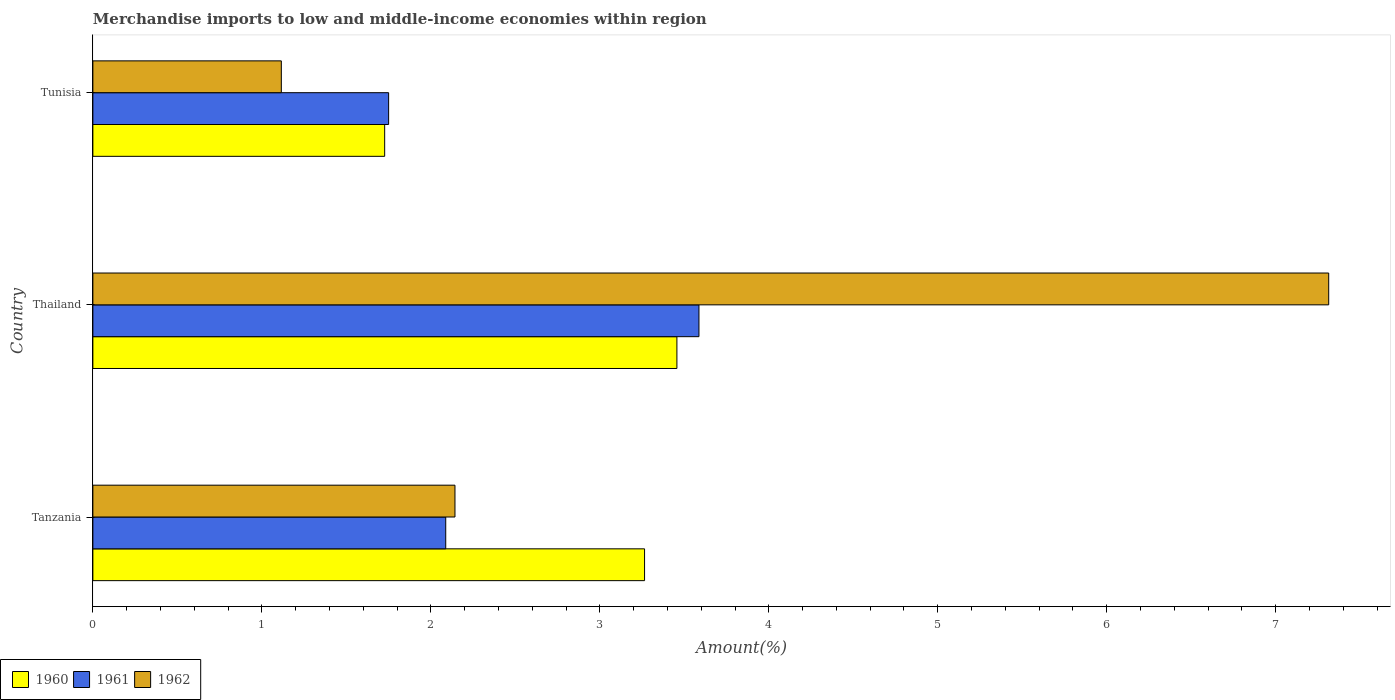Are the number of bars per tick equal to the number of legend labels?
Make the answer very short. Yes. How many bars are there on the 3rd tick from the bottom?
Keep it short and to the point. 3. What is the label of the 2nd group of bars from the top?
Your response must be concise. Thailand. In how many cases, is the number of bars for a given country not equal to the number of legend labels?
Your answer should be compact. 0. What is the percentage of amount earned from merchandise imports in 1960 in Tunisia?
Ensure brevity in your answer.  1.73. Across all countries, what is the maximum percentage of amount earned from merchandise imports in 1960?
Offer a terse response. 3.46. Across all countries, what is the minimum percentage of amount earned from merchandise imports in 1962?
Offer a very short reply. 1.12. In which country was the percentage of amount earned from merchandise imports in 1961 maximum?
Keep it short and to the point. Thailand. In which country was the percentage of amount earned from merchandise imports in 1961 minimum?
Your answer should be very brief. Tunisia. What is the total percentage of amount earned from merchandise imports in 1961 in the graph?
Keep it short and to the point. 7.43. What is the difference between the percentage of amount earned from merchandise imports in 1961 in Tanzania and that in Tunisia?
Your response must be concise. 0.34. What is the difference between the percentage of amount earned from merchandise imports in 1962 in Tunisia and the percentage of amount earned from merchandise imports in 1961 in Tanzania?
Your answer should be very brief. -0.97. What is the average percentage of amount earned from merchandise imports in 1960 per country?
Offer a very short reply. 2.82. What is the difference between the percentage of amount earned from merchandise imports in 1960 and percentage of amount earned from merchandise imports in 1962 in Tanzania?
Offer a terse response. 1.12. What is the ratio of the percentage of amount earned from merchandise imports in 1962 in Thailand to that in Tunisia?
Offer a terse response. 6.56. What is the difference between the highest and the second highest percentage of amount earned from merchandise imports in 1960?
Your response must be concise. 0.19. What is the difference between the highest and the lowest percentage of amount earned from merchandise imports in 1961?
Offer a terse response. 1.84. Is the sum of the percentage of amount earned from merchandise imports in 1960 in Tanzania and Tunisia greater than the maximum percentage of amount earned from merchandise imports in 1961 across all countries?
Your answer should be compact. Yes. What does the 3rd bar from the top in Tanzania represents?
Keep it short and to the point. 1960. What does the 2nd bar from the bottom in Tunisia represents?
Keep it short and to the point. 1961. Is it the case that in every country, the sum of the percentage of amount earned from merchandise imports in 1960 and percentage of amount earned from merchandise imports in 1962 is greater than the percentage of amount earned from merchandise imports in 1961?
Provide a succinct answer. Yes. Are the values on the major ticks of X-axis written in scientific E-notation?
Your answer should be very brief. No. How many legend labels are there?
Your answer should be compact. 3. What is the title of the graph?
Ensure brevity in your answer.  Merchandise imports to low and middle-income economies within region. Does "1982" appear as one of the legend labels in the graph?
Your answer should be compact. No. What is the label or title of the X-axis?
Ensure brevity in your answer.  Amount(%). What is the label or title of the Y-axis?
Provide a succinct answer. Country. What is the Amount(%) in 1960 in Tanzania?
Your response must be concise. 3.26. What is the Amount(%) in 1961 in Tanzania?
Your response must be concise. 2.09. What is the Amount(%) in 1962 in Tanzania?
Offer a terse response. 2.14. What is the Amount(%) in 1960 in Thailand?
Your response must be concise. 3.46. What is the Amount(%) in 1961 in Thailand?
Your answer should be very brief. 3.59. What is the Amount(%) in 1962 in Thailand?
Make the answer very short. 7.31. What is the Amount(%) in 1960 in Tunisia?
Provide a succinct answer. 1.73. What is the Amount(%) in 1961 in Tunisia?
Provide a short and direct response. 1.75. What is the Amount(%) in 1962 in Tunisia?
Provide a short and direct response. 1.12. Across all countries, what is the maximum Amount(%) of 1960?
Ensure brevity in your answer.  3.46. Across all countries, what is the maximum Amount(%) of 1961?
Make the answer very short. 3.59. Across all countries, what is the maximum Amount(%) of 1962?
Provide a succinct answer. 7.31. Across all countries, what is the minimum Amount(%) in 1960?
Give a very brief answer. 1.73. Across all countries, what is the minimum Amount(%) of 1961?
Offer a terse response. 1.75. Across all countries, what is the minimum Amount(%) of 1962?
Keep it short and to the point. 1.12. What is the total Amount(%) of 1960 in the graph?
Provide a succinct answer. 8.45. What is the total Amount(%) of 1961 in the graph?
Give a very brief answer. 7.43. What is the total Amount(%) in 1962 in the graph?
Offer a very short reply. 10.57. What is the difference between the Amount(%) of 1960 in Tanzania and that in Thailand?
Your response must be concise. -0.19. What is the difference between the Amount(%) of 1961 in Tanzania and that in Thailand?
Ensure brevity in your answer.  -1.5. What is the difference between the Amount(%) of 1962 in Tanzania and that in Thailand?
Provide a succinct answer. -5.17. What is the difference between the Amount(%) of 1960 in Tanzania and that in Tunisia?
Give a very brief answer. 1.54. What is the difference between the Amount(%) in 1961 in Tanzania and that in Tunisia?
Give a very brief answer. 0.34. What is the difference between the Amount(%) of 1962 in Tanzania and that in Tunisia?
Offer a very short reply. 1.03. What is the difference between the Amount(%) of 1960 in Thailand and that in Tunisia?
Make the answer very short. 1.73. What is the difference between the Amount(%) in 1961 in Thailand and that in Tunisia?
Make the answer very short. 1.84. What is the difference between the Amount(%) in 1962 in Thailand and that in Tunisia?
Your response must be concise. 6.2. What is the difference between the Amount(%) in 1960 in Tanzania and the Amount(%) in 1961 in Thailand?
Provide a short and direct response. -0.32. What is the difference between the Amount(%) of 1960 in Tanzania and the Amount(%) of 1962 in Thailand?
Your answer should be compact. -4.05. What is the difference between the Amount(%) of 1961 in Tanzania and the Amount(%) of 1962 in Thailand?
Keep it short and to the point. -5.23. What is the difference between the Amount(%) of 1960 in Tanzania and the Amount(%) of 1961 in Tunisia?
Provide a succinct answer. 1.51. What is the difference between the Amount(%) of 1960 in Tanzania and the Amount(%) of 1962 in Tunisia?
Your answer should be very brief. 2.15. What is the difference between the Amount(%) of 1961 in Tanzania and the Amount(%) of 1962 in Tunisia?
Your answer should be compact. 0.97. What is the difference between the Amount(%) of 1960 in Thailand and the Amount(%) of 1961 in Tunisia?
Provide a succinct answer. 1.71. What is the difference between the Amount(%) in 1960 in Thailand and the Amount(%) in 1962 in Tunisia?
Provide a short and direct response. 2.34. What is the difference between the Amount(%) in 1961 in Thailand and the Amount(%) in 1962 in Tunisia?
Give a very brief answer. 2.47. What is the average Amount(%) of 1960 per country?
Offer a terse response. 2.82. What is the average Amount(%) of 1961 per country?
Ensure brevity in your answer.  2.48. What is the average Amount(%) of 1962 per country?
Offer a very short reply. 3.52. What is the difference between the Amount(%) in 1960 and Amount(%) in 1961 in Tanzania?
Provide a succinct answer. 1.18. What is the difference between the Amount(%) of 1960 and Amount(%) of 1962 in Tanzania?
Your answer should be compact. 1.12. What is the difference between the Amount(%) in 1961 and Amount(%) in 1962 in Tanzania?
Ensure brevity in your answer.  -0.05. What is the difference between the Amount(%) of 1960 and Amount(%) of 1961 in Thailand?
Your answer should be very brief. -0.13. What is the difference between the Amount(%) in 1960 and Amount(%) in 1962 in Thailand?
Your answer should be very brief. -3.86. What is the difference between the Amount(%) of 1961 and Amount(%) of 1962 in Thailand?
Offer a very short reply. -3.73. What is the difference between the Amount(%) of 1960 and Amount(%) of 1961 in Tunisia?
Give a very brief answer. -0.02. What is the difference between the Amount(%) of 1960 and Amount(%) of 1962 in Tunisia?
Give a very brief answer. 0.61. What is the difference between the Amount(%) of 1961 and Amount(%) of 1962 in Tunisia?
Provide a succinct answer. 0.64. What is the ratio of the Amount(%) of 1960 in Tanzania to that in Thailand?
Offer a very short reply. 0.94. What is the ratio of the Amount(%) in 1961 in Tanzania to that in Thailand?
Make the answer very short. 0.58. What is the ratio of the Amount(%) of 1962 in Tanzania to that in Thailand?
Your answer should be compact. 0.29. What is the ratio of the Amount(%) in 1960 in Tanzania to that in Tunisia?
Your answer should be very brief. 1.89. What is the ratio of the Amount(%) in 1961 in Tanzania to that in Tunisia?
Provide a succinct answer. 1.19. What is the ratio of the Amount(%) of 1962 in Tanzania to that in Tunisia?
Keep it short and to the point. 1.92. What is the ratio of the Amount(%) of 1960 in Thailand to that in Tunisia?
Offer a terse response. 2. What is the ratio of the Amount(%) in 1961 in Thailand to that in Tunisia?
Offer a terse response. 2.05. What is the ratio of the Amount(%) of 1962 in Thailand to that in Tunisia?
Your answer should be very brief. 6.56. What is the difference between the highest and the second highest Amount(%) in 1960?
Your answer should be compact. 0.19. What is the difference between the highest and the second highest Amount(%) of 1961?
Ensure brevity in your answer.  1.5. What is the difference between the highest and the second highest Amount(%) in 1962?
Make the answer very short. 5.17. What is the difference between the highest and the lowest Amount(%) of 1960?
Ensure brevity in your answer.  1.73. What is the difference between the highest and the lowest Amount(%) in 1961?
Provide a succinct answer. 1.84. What is the difference between the highest and the lowest Amount(%) in 1962?
Keep it short and to the point. 6.2. 